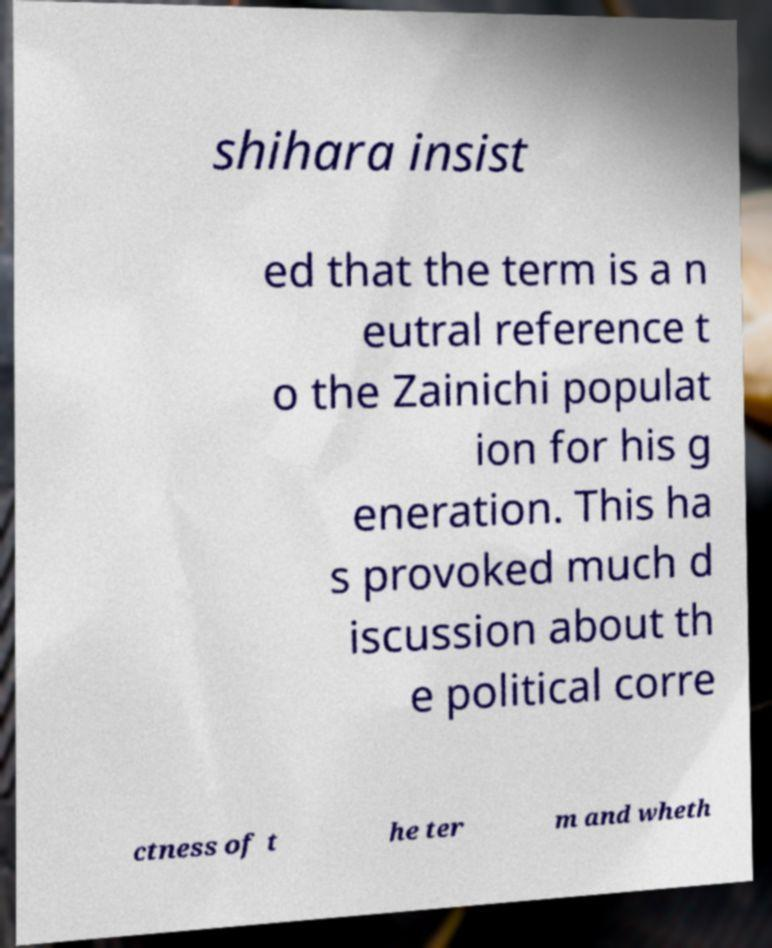I need the written content from this picture converted into text. Can you do that? shihara insist ed that the term is a n eutral reference t o the Zainichi populat ion for his g eneration. This ha s provoked much d iscussion about th e political corre ctness of t he ter m and wheth 